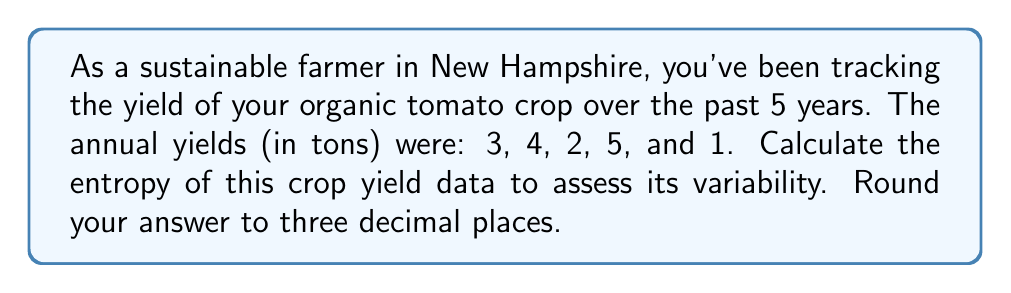Can you solve this math problem? To calculate the entropy of the crop yield data, we'll use the formula for Shannon entropy:

$$H = -\sum_{i=1}^{n} p_i \log_2(p_i)$$

Where $p_i$ is the probability of each outcome.

Steps:
1) First, we need to calculate the probability of each yield outcome:
   Total yield = 3 + 4 + 2 + 5 + 1 = 15 tons
   
   $p(1) = 1/15$
   $p(2) = 2/15$
   $p(3) = 3/15 = 1/5$
   $p(4) = 4/15$
   $p(5) = 5/15 = 1/3$

2) Now, we can apply the entropy formula:

   $$H = -(\frac{1}{15} \log_2(\frac{1}{15}) + \frac{2}{15} \log_2(\frac{2}{15}) + \frac{1}{5} \log_2(\frac{1}{5}) + \frac{4}{15} \log_2(\frac{4}{15}) + \frac{1}{3} \log_2(\frac{1}{3}))$$

3) Calculating each term:
   $\frac{1}{15} \log_2(\frac{1}{15}) \approx 0.2603$
   $\frac{2}{15} \log_2(\frac{2}{15}) \approx 0.3685$
   $\frac{1}{5} \log_2(\frac{1}{5}) \approx 0.4644$
   $\frac{4}{15} \log_2(\frac{4}{15}) \approx 0.5177$
   $\frac{1}{3} \log_2(\frac{1}{3}) \approx 0.5283$

4) Sum the negative of these values:
   $H = -(0.2603 + 0.3685 + 0.4644 + 0.5177 + 0.5283) \approx 2.1392$

5) Rounding to three decimal places: 2.139
Answer: 2.139 